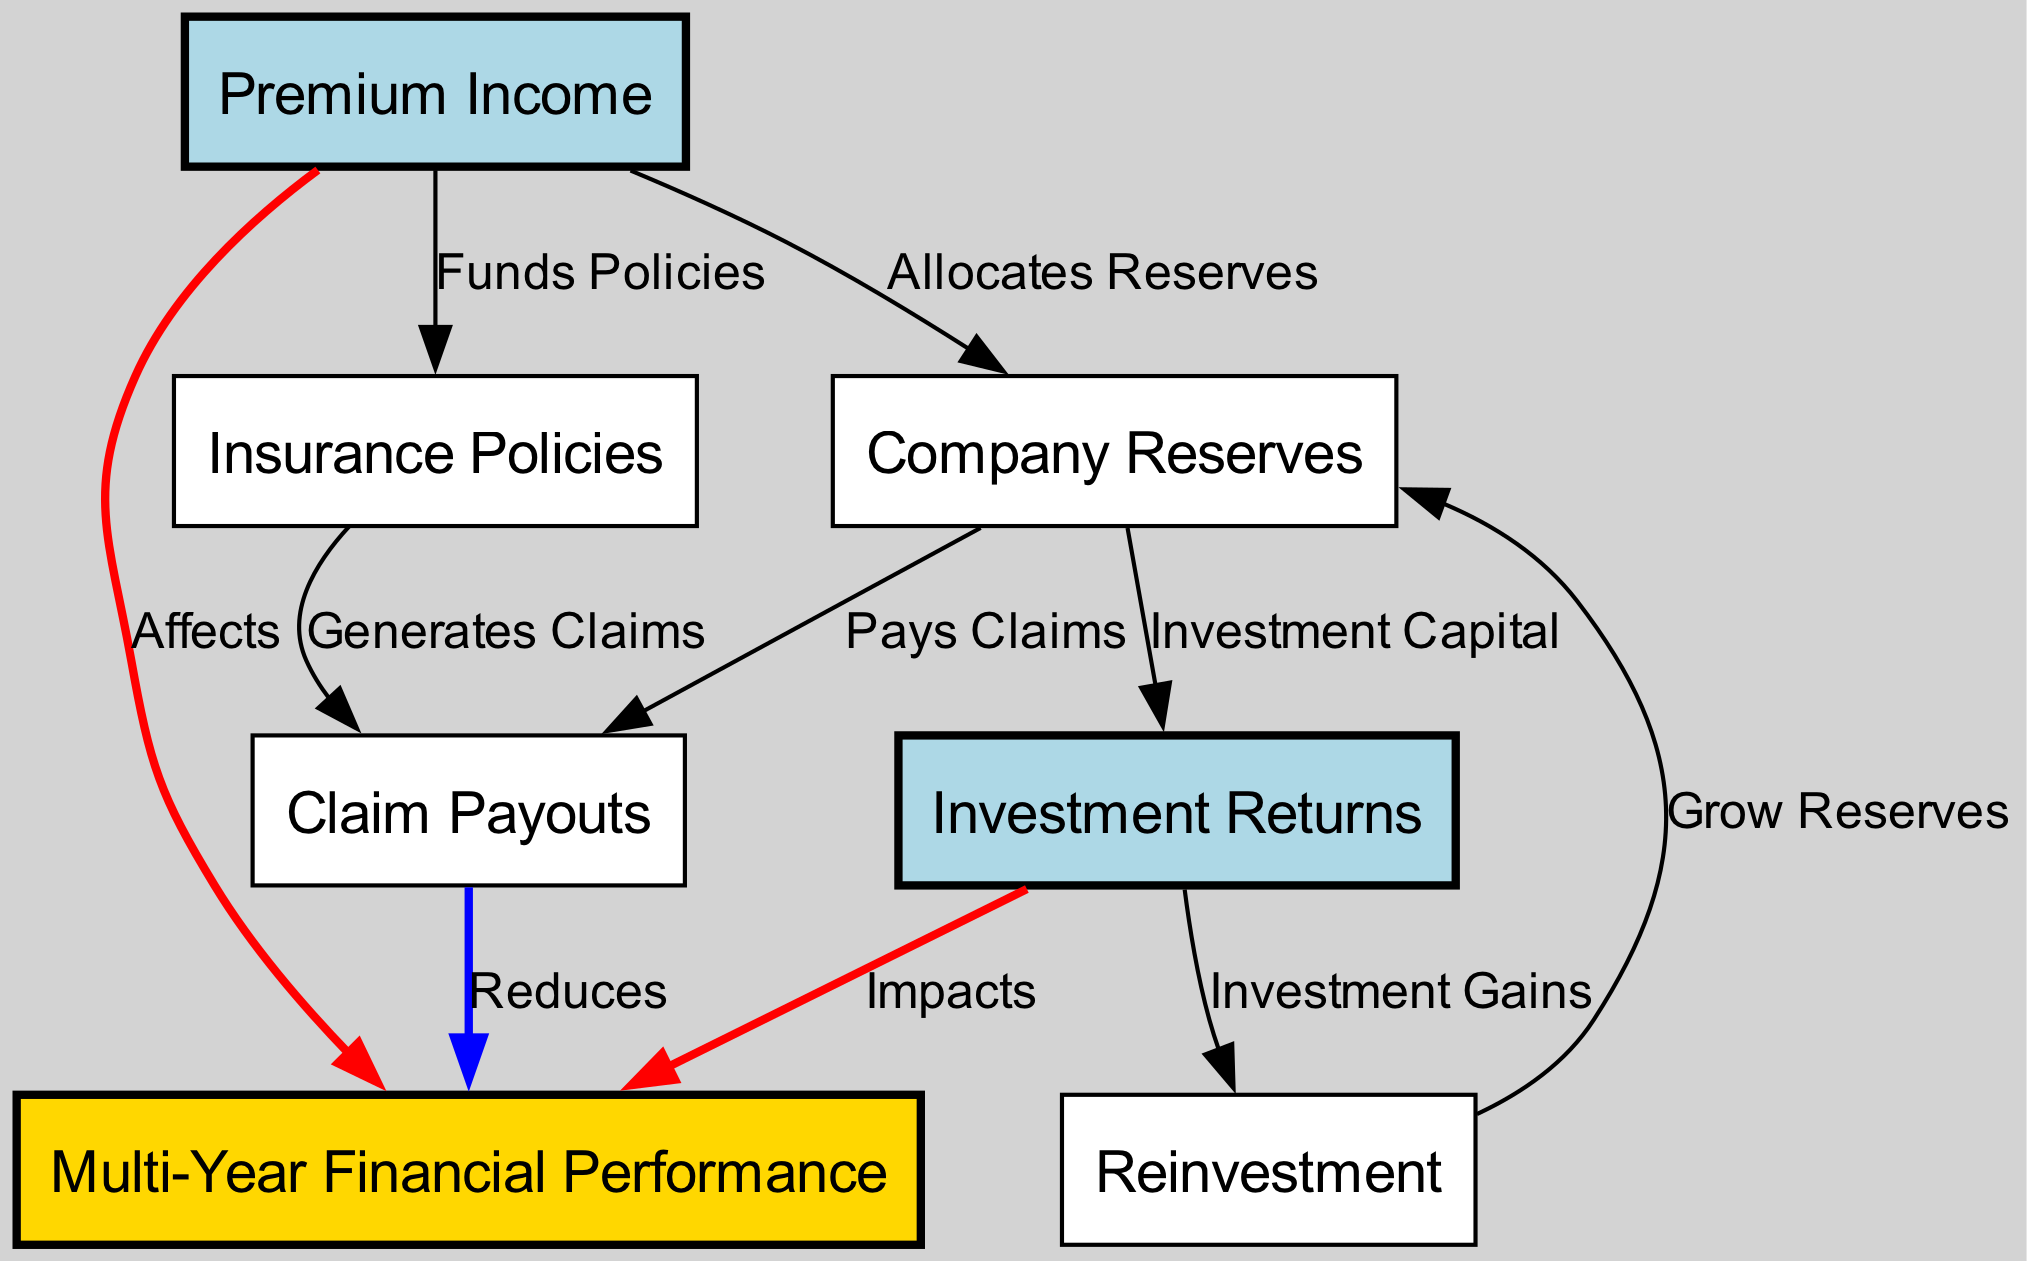What is the label of the node connected to Premium Income? The diagram shows that Premium Income is connected to two nodes: Insurance Policies and Company Reserves. The label of the first node it connects to is "Insurance Policies".
Answer: Insurance Policies How many total nodes are in the diagram? Counting the entries in the nodes list, we find there are six nodes in total: Premium Income, Investment Returns, Insurance Policies, Claim Payouts, Company Reserves, and Reinvestment.
Answer: Six What relationship does Claim Payouts have with Multi-Year Financial Performance? The edge from Claim Payouts to Multi-Year Financial Performance indicates that Claim Payouts "Reduces" Multi-Year Financial Performance. This implies a negative impact of Claim Payouts on Multi-Year Financial Performance.
Answer: Reduces What is the primary function of Investment Returns in the diagram? Investment Returns has a direct connection to Multi-Year Financial Performance, with an edge that states it "Impacts" this performance measure. The edge indicates a positive contribution of investment returns to financial performance.
Answer: Impacts What does Company Reserves do with Claim Payouts? The diagram explicitly shows that Company Reserves "Pays Claims" to Claim Payouts, indicating a flow of funds from reserves to cover the claims made.
Answer: Pays Claims How does Premium Income influence Multi-Year Financial Performance? The edge labeled "Affects" shows a direct connection from Premium Income to Multi-Year Financial Performance, meaning that the income generated from premiums has an effect on the overall financial performance over multiple years.
Answer: Affects What does Reinvestment rely on according to the diagram? The diagram shows that Reinvestment is entirely dependent on Investment Gains from Investment Returns, suggesting that reinvestment activities are funded by the returns from investments.
Answer: Investment Gains How do both Premium Income and Investment Returns relate to Multi-Year Financial Performance? Both nodes are shown connected to Multi-Year Financial Performance, with edges indicating that Premium Income "Affects" and Investment Returns "Impacts" this performance, suggesting a dual influence on the financial outcome.
Answer: Affects and Impacts 